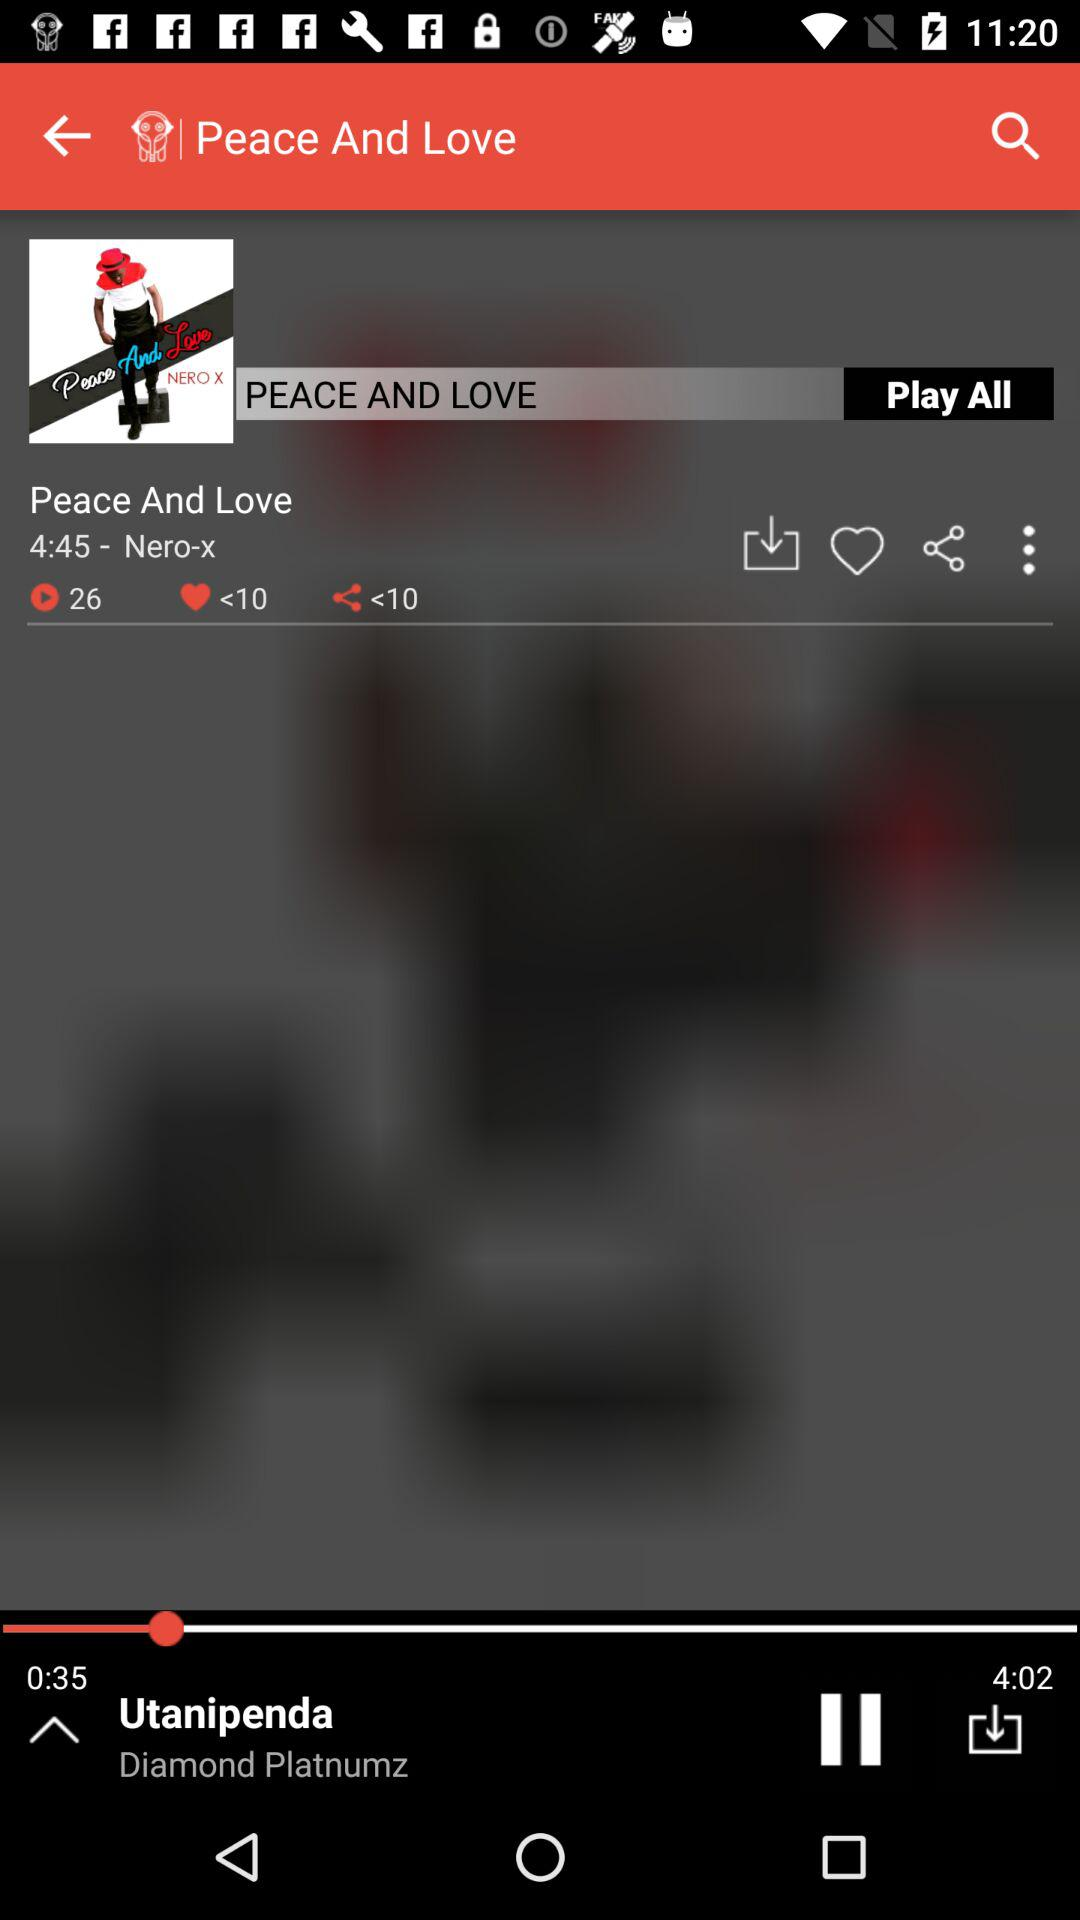What is the number of likes? The number of likes is "<10". 